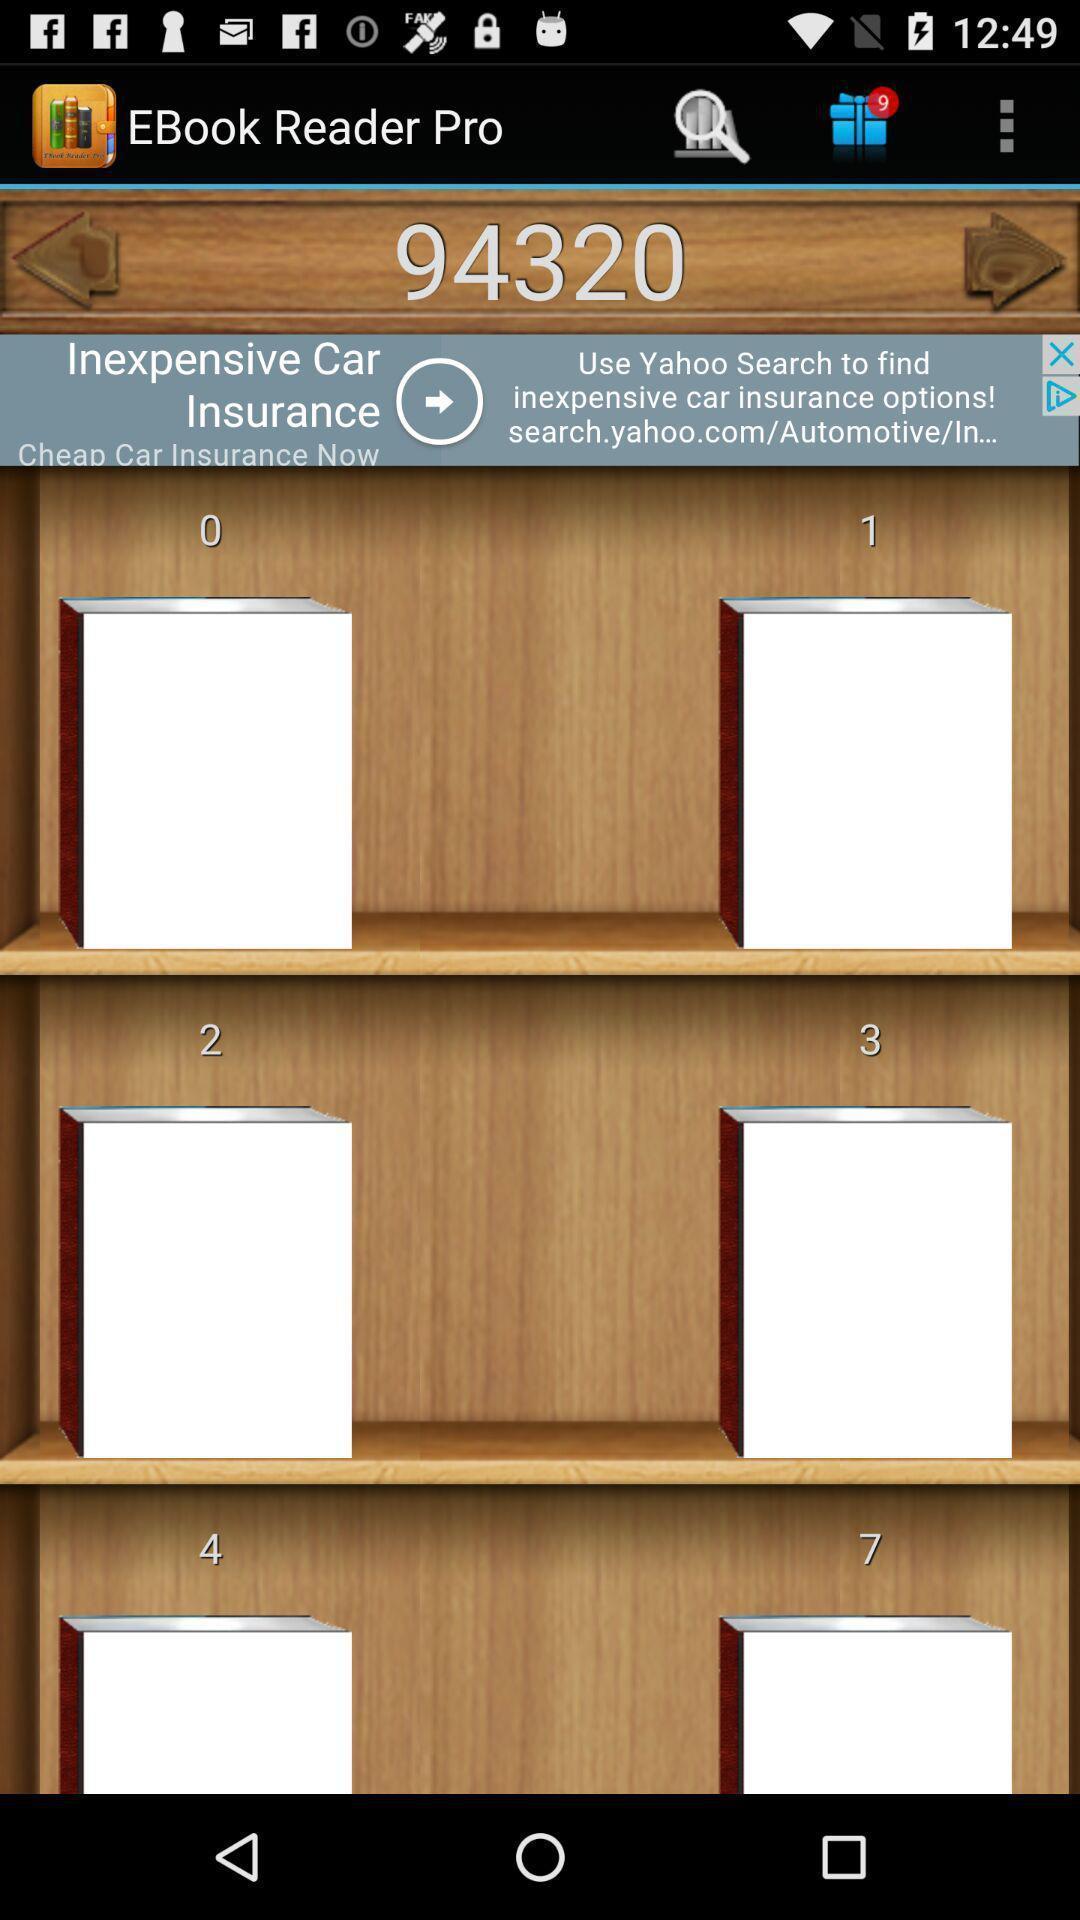What details can you identify in this image? Screen page of a book reader app. 